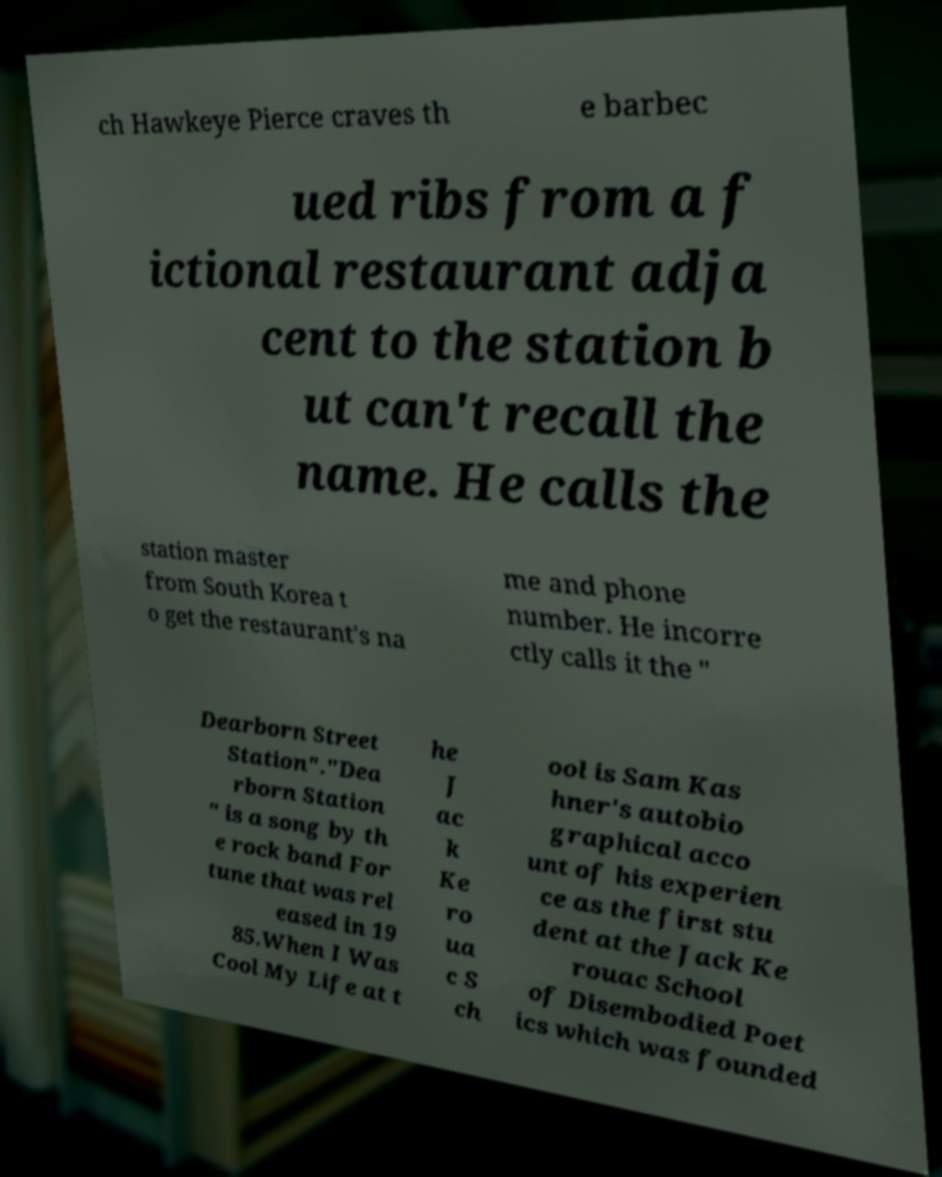Please identify and transcribe the text found in this image. ch Hawkeye Pierce craves th e barbec ued ribs from a f ictional restaurant adja cent to the station b ut can't recall the name. He calls the station master from South Korea t o get the restaurant's na me and phone number. He incorre ctly calls it the " Dearborn Street Station"."Dea rborn Station " is a song by th e rock band For tune that was rel eased in 19 85.When I Was Cool My Life at t he J ac k Ke ro ua c S ch ool is Sam Kas hner's autobio graphical acco unt of his experien ce as the first stu dent at the Jack Ke rouac School of Disembodied Poet ics which was founded 